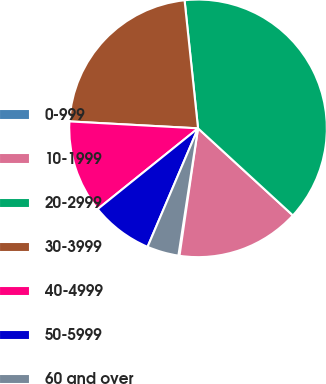<chart> <loc_0><loc_0><loc_500><loc_500><pie_chart><fcel>0-999<fcel>10-1999<fcel>20-2999<fcel>30-3999<fcel>40-4999<fcel>50-5999<fcel>60 and over<nl><fcel>0.14%<fcel>15.48%<fcel>38.49%<fcel>22.48%<fcel>11.64%<fcel>7.81%<fcel>3.97%<nl></chart> 